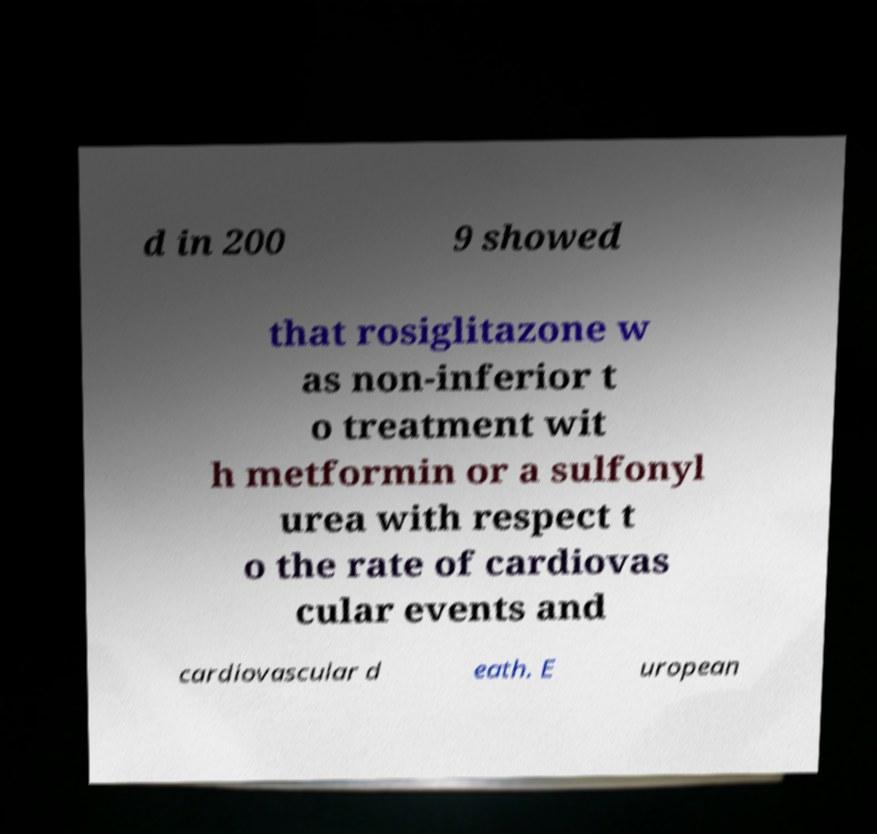For documentation purposes, I need the text within this image transcribed. Could you provide that? d in 200 9 showed that rosiglitazone w as non-inferior t o treatment wit h metformin or a sulfonyl urea with respect t o the rate of cardiovas cular events and cardiovascular d eath. E uropean 